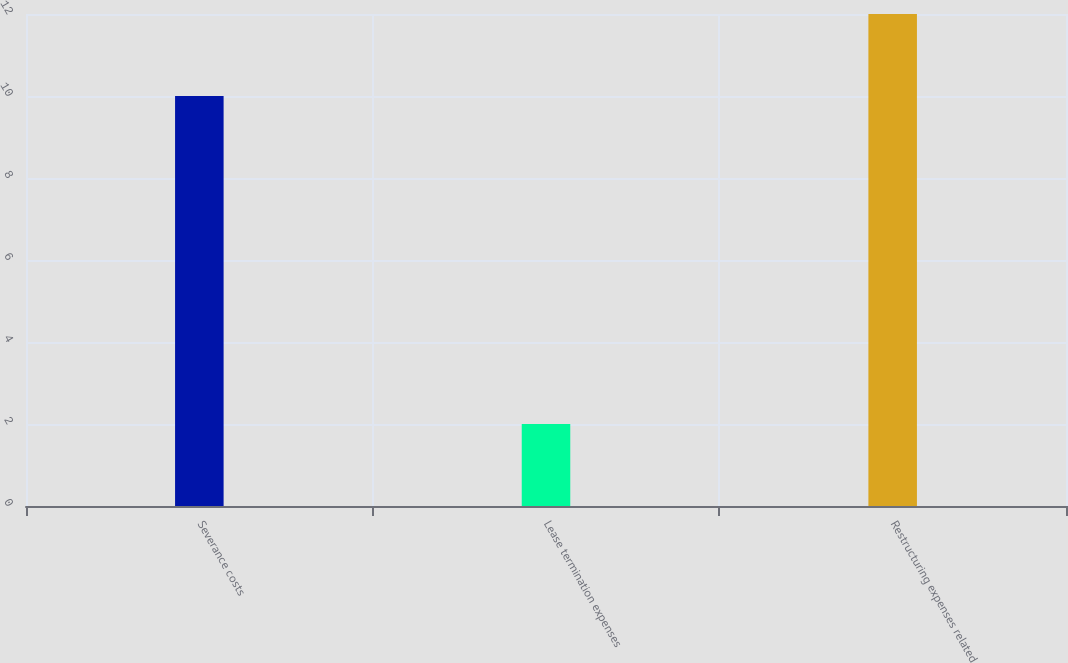Convert chart. <chart><loc_0><loc_0><loc_500><loc_500><bar_chart><fcel>Severance costs<fcel>Lease termination expenses<fcel>Restructuring expenses related<nl><fcel>10<fcel>2<fcel>12<nl></chart> 